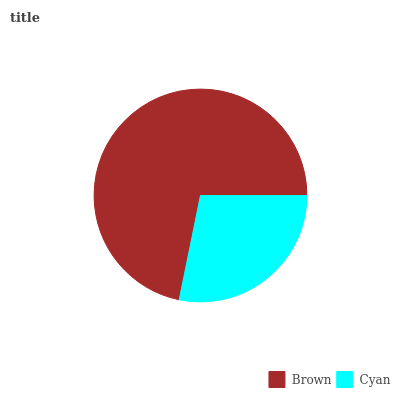Is Cyan the minimum?
Answer yes or no. Yes. Is Brown the maximum?
Answer yes or no. Yes. Is Cyan the maximum?
Answer yes or no. No. Is Brown greater than Cyan?
Answer yes or no. Yes. Is Cyan less than Brown?
Answer yes or no. Yes. Is Cyan greater than Brown?
Answer yes or no. No. Is Brown less than Cyan?
Answer yes or no. No. Is Brown the high median?
Answer yes or no. Yes. Is Cyan the low median?
Answer yes or no. Yes. Is Cyan the high median?
Answer yes or no. No. Is Brown the low median?
Answer yes or no. No. 